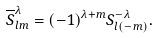<formula> <loc_0><loc_0><loc_500><loc_500>\overline { S } ^ { \lambda } _ { l m } = ( - 1 ) ^ { \lambda + m } S ^ { - \lambda } _ { l ( - m ) } .</formula> 